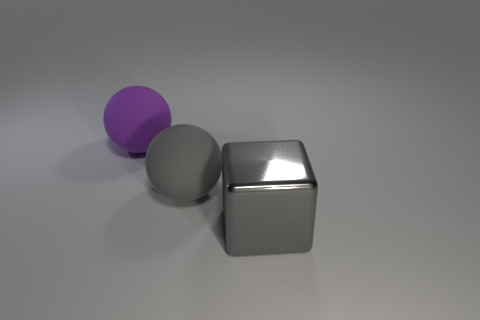Add 3 gray metal cubes. How many objects exist? 6 Subtract all gray balls. How many balls are left? 1 Subtract all blocks. How many objects are left? 2 Subtract 1 spheres. How many spheres are left? 1 Subtract 0 green balls. How many objects are left? 3 Subtract all yellow cubes. Subtract all brown cylinders. How many cubes are left? 1 Subtract all small yellow metallic cylinders. Subtract all big purple objects. How many objects are left? 2 Add 3 large cubes. How many large cubes are left? 4 Add 2 large purple objects. How many large purple objects exist? 3 